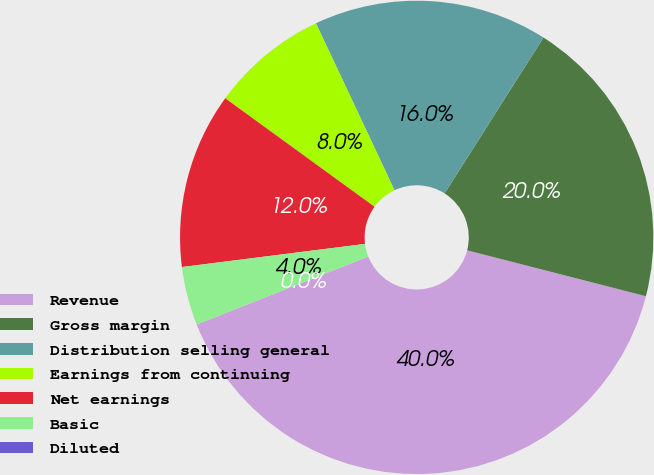<chart> <loc_0><loc_0><loc_500><loc_500><pie_chart><fcel>Revenue<fcel>Gross margin<fcel>Distribution selling general<fcel>Earnings from continuing<fcel>Net earnings<fcel>Basic<fcel>Diluted<nl><fcel>40.0%<fcel>20.0%<fcel>16.0%<fcel>8.0%<fcel>12.0%<fcel>4.0%<fcel>0.0%<nl></chart> 